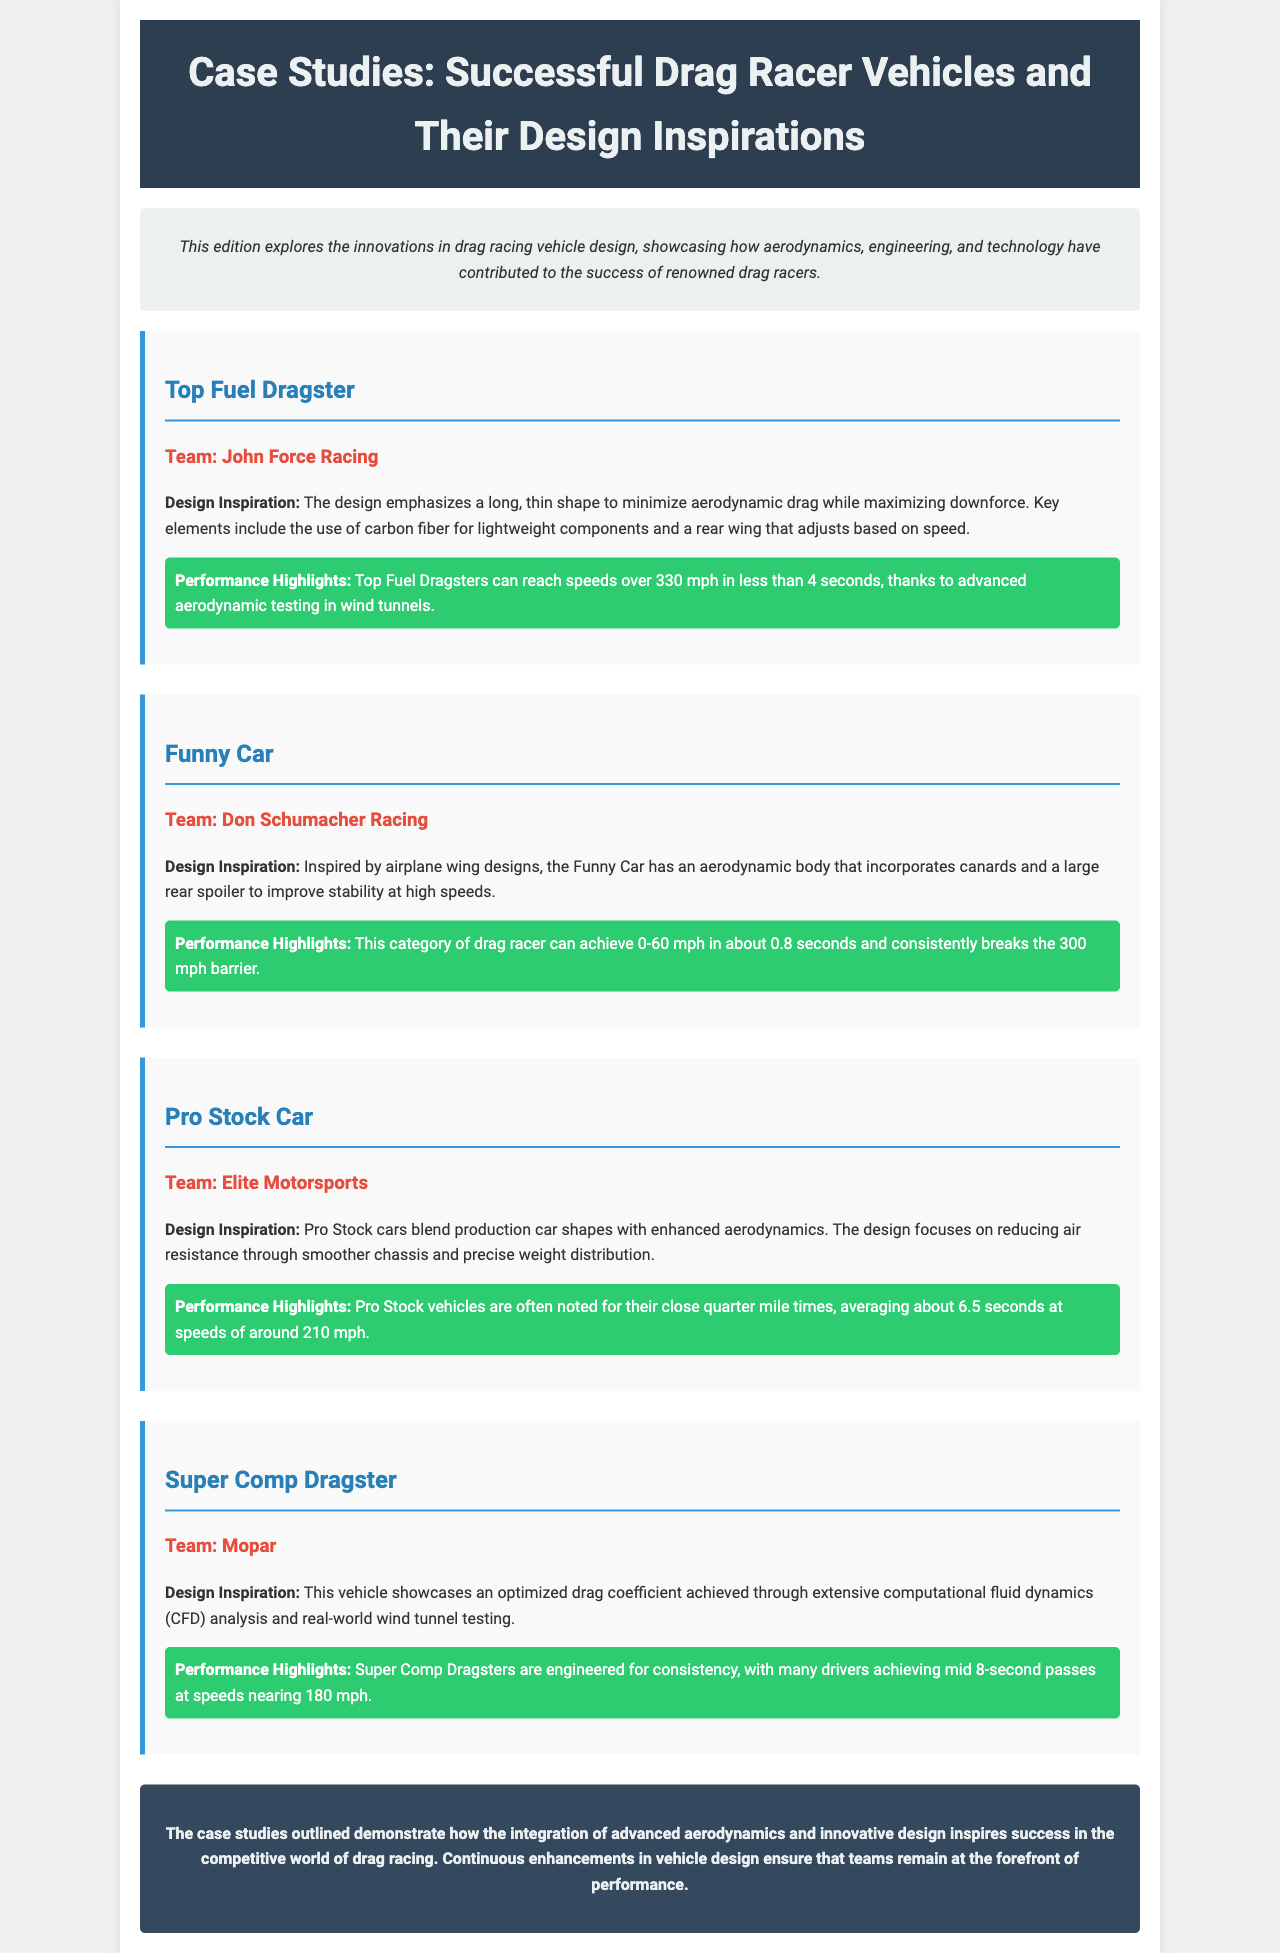What is the team associated with the Top Fuel Dragster? The document states that the Top Fuel Dragster is associated with John Force Racing.
Answer: John Force Racing What design element helps the Funny Car improve stability? The document mentions that the Funny Car incorporates a large rear spoiler to improve stability at high speeds.
Answer: Large rear spoiler What is the average quarter mile time for Pro Stock vehicles? According to the document, Pro Stock vehicles average about 6.5 seconds at the quarter mile.
Answer: 6.5 seconds What technology is highlighted in the design inspiration of the Super Comp Dragster? The document emphasizes that the Super Comp Dragster design is achieved through extensive computational fluid dynamics (CFD) analysis.
Answer: Computational fluid dynamics What is a key performance highlight of Top Fuel Dragsters? The performance highlight noted in the document is that they can reach speeds over 330 mph in less than 4 seconds.
Answer: 330 mph Which team is associated with the Pro Stock Car? The document specifies that the Pro Stock Car is associated with Elite Motorsports.
Answer: Elite Motorsports What design inspiration does the Funny Car draw from? The document states that the Funny Car is inspired by airplane wing designs.
Answer: Airplane wing designs What material is used for lightweight components in Top Fuel Dragster design? The document indicates that carbon fiber is used for lightweight components in the Top Fuel Dragster design.
Answer: Carbon fiber What aspect of vehicle performance does the drag coefficient optimization of the Super Comp Dragster affect? The document outlines that the optimization of the drag coefficient affects speed and consistency in performance.
Answer: Speed and consistency 